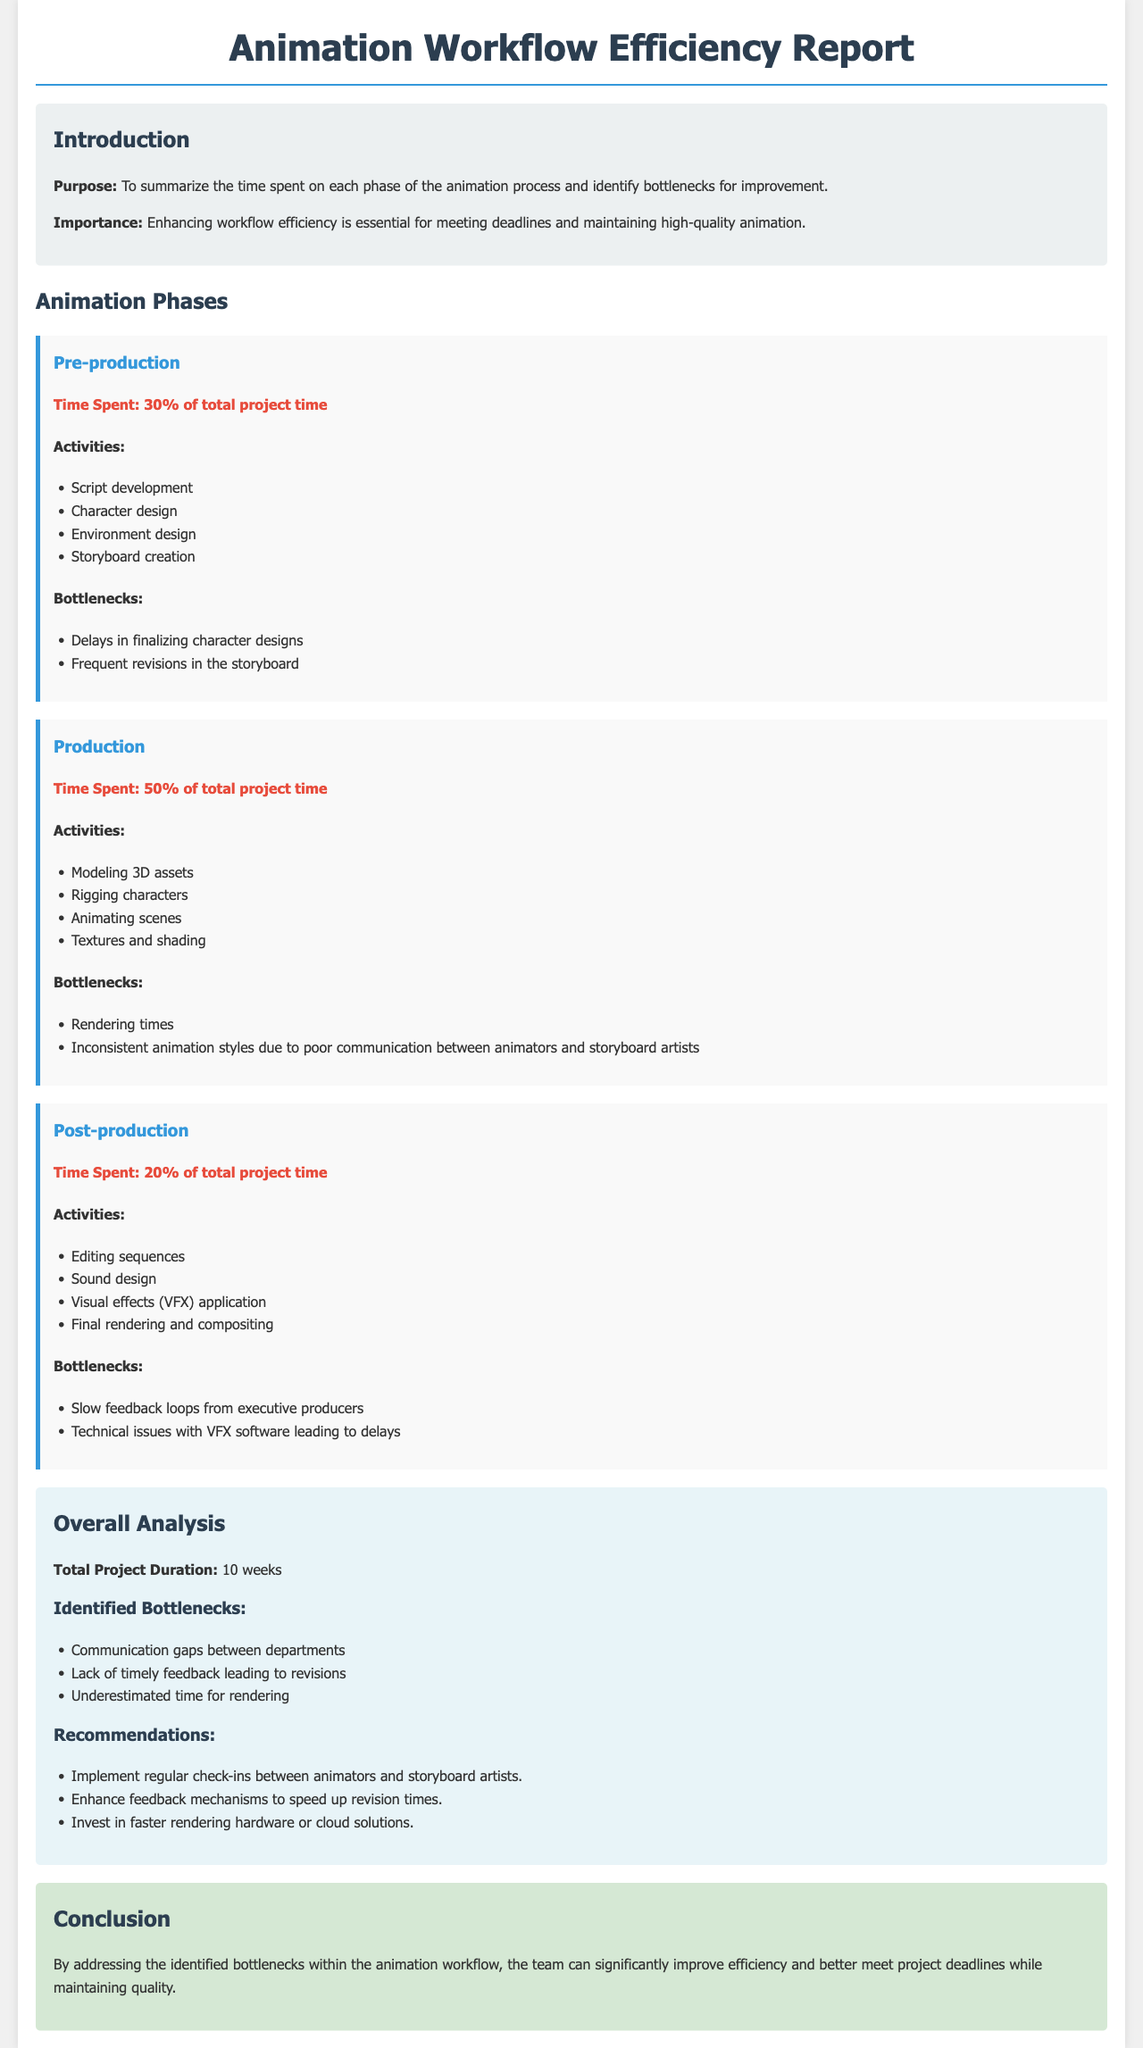What percentage of total project time is spent in Pre-production? The document states that 30% of the total project time is spent in the Pre-production phase.
Answer: 30% What is the time spent on Production? According to the report, 50% of the total project time is allocated to Production.
Answer: 50% What is the total project duration? The report explicitly mentions that the total project duration is 10 weeks.
Answer: 10 weeks What bottleneck is identified in the Production phase? One of the bottlenecks listed in the Production phase is "Rendering times."
Answer: Rendering times What recommendation is given to improve communication? The document suggests implementing "regular check-ins between animators and storyboard artists" as a recommendation.
Answer: regular check-ins between animators and storyboard artists What activity is included in the Post-production phase? The report lists "Sound design" as one of the activities in the Post-production phase.
Answer: Sound design Which phase has the least amount of time spent? In the document, it is stated that Post-production has the least time spent at 20%.
Answer: Post-production What is the importance of enhancing workflow efficiency? The document highlights that enhancing workflow efficiency is essential for meeting deadlines and maintaining high-quality animation.
Answer: meeting deadlines and maintaining high-quality animation 